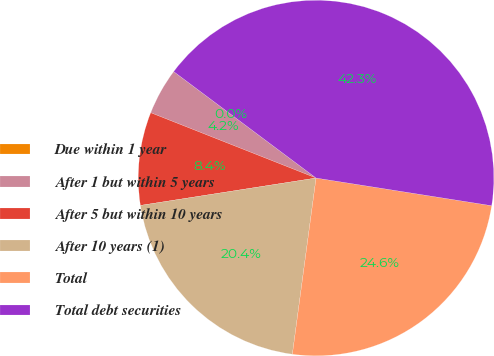Convert chart. <chart><loc_0><loc_0><loc_500><loc_500><pie_chart><fcel>Due within 1 year<fcel>After 1 but within 5 years<fcel>After 5 but within 10 years<fcel>After 10 years (1)<fcel>Total<fcel>Total debt securities<nl><fcel>0.0%<fcel>4.23%<fcel>8.45%<fcel>20.41%<fcel>24.64%<fcel>42.27%<nl></chart> 